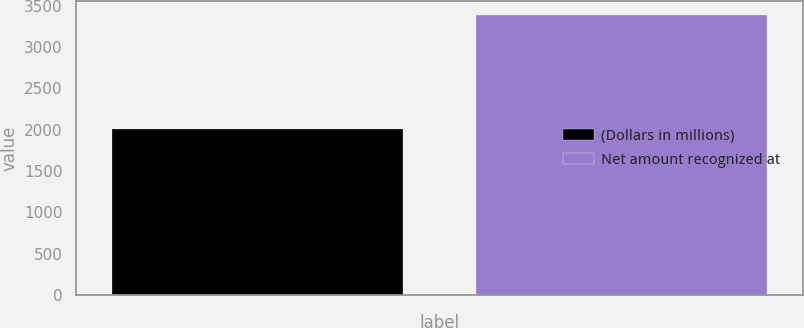Convert chart to OTSL. <chart><loc_0><loc_0><loc_500><loc_500><bar_chart><fcel>(Dollars in millions)<fcel>Net amount recognized at<nl><fcel>2004<fcel>3384<nl></chart> 